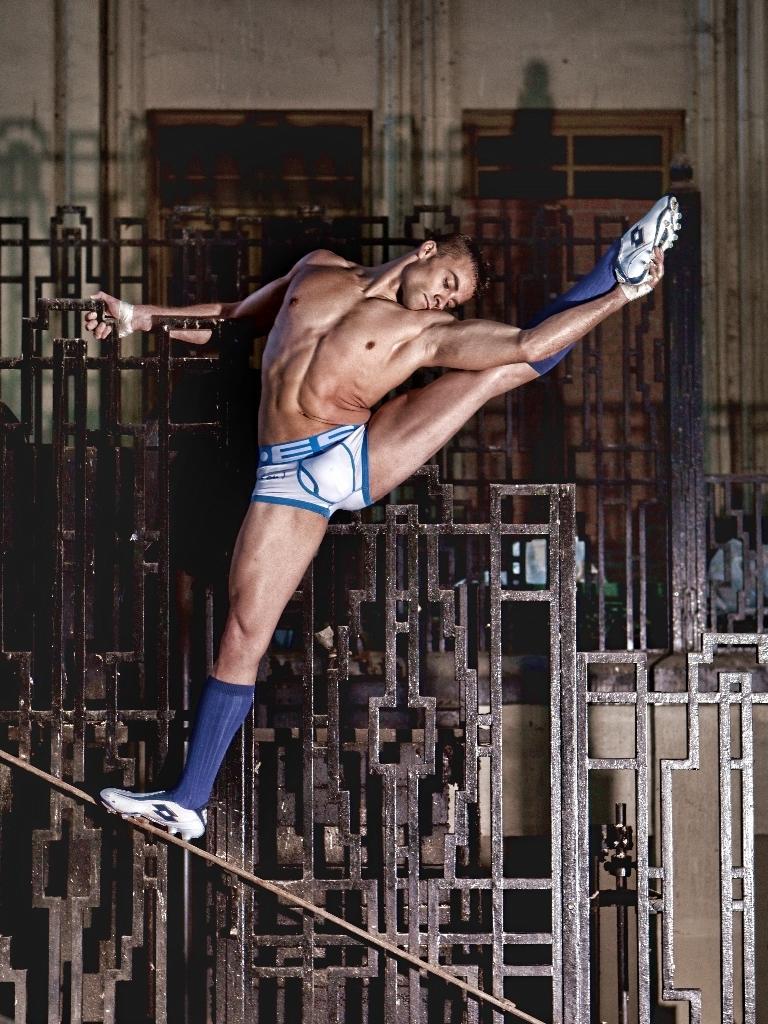Describe this image in one or two sentences. In this image we can see a man is standing on the rod, at the back here are the metal rods, here is the wall. 